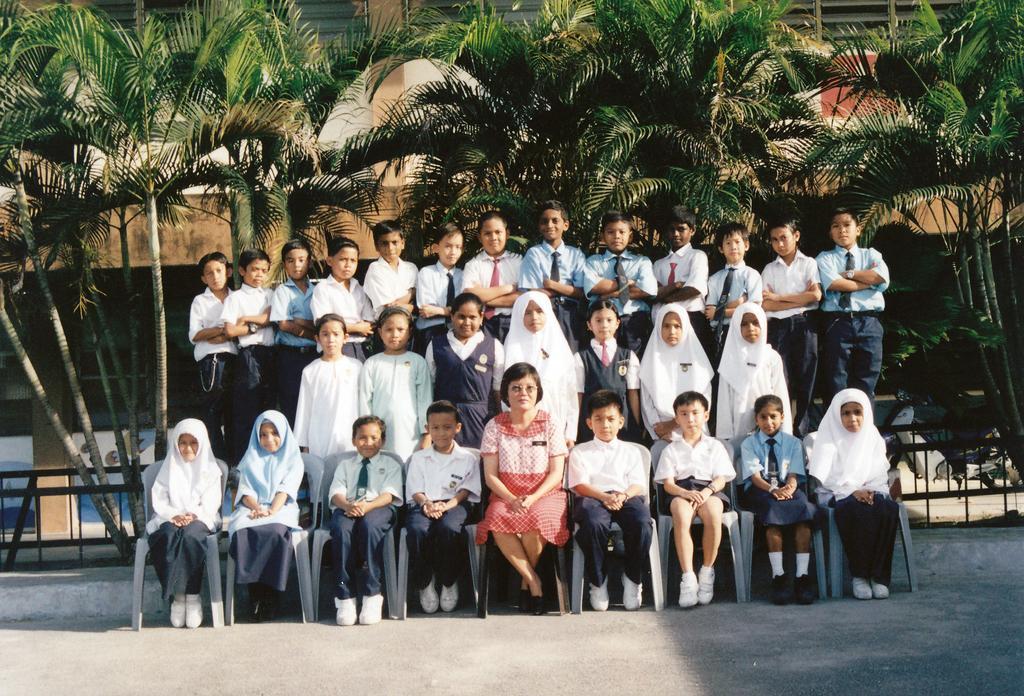In one or two sentences, can you explain what this image depicts? In this picture we can see group of people, few are sitting on the chairs and few are standing, behind them we can see few trees, metal rods and a building. 